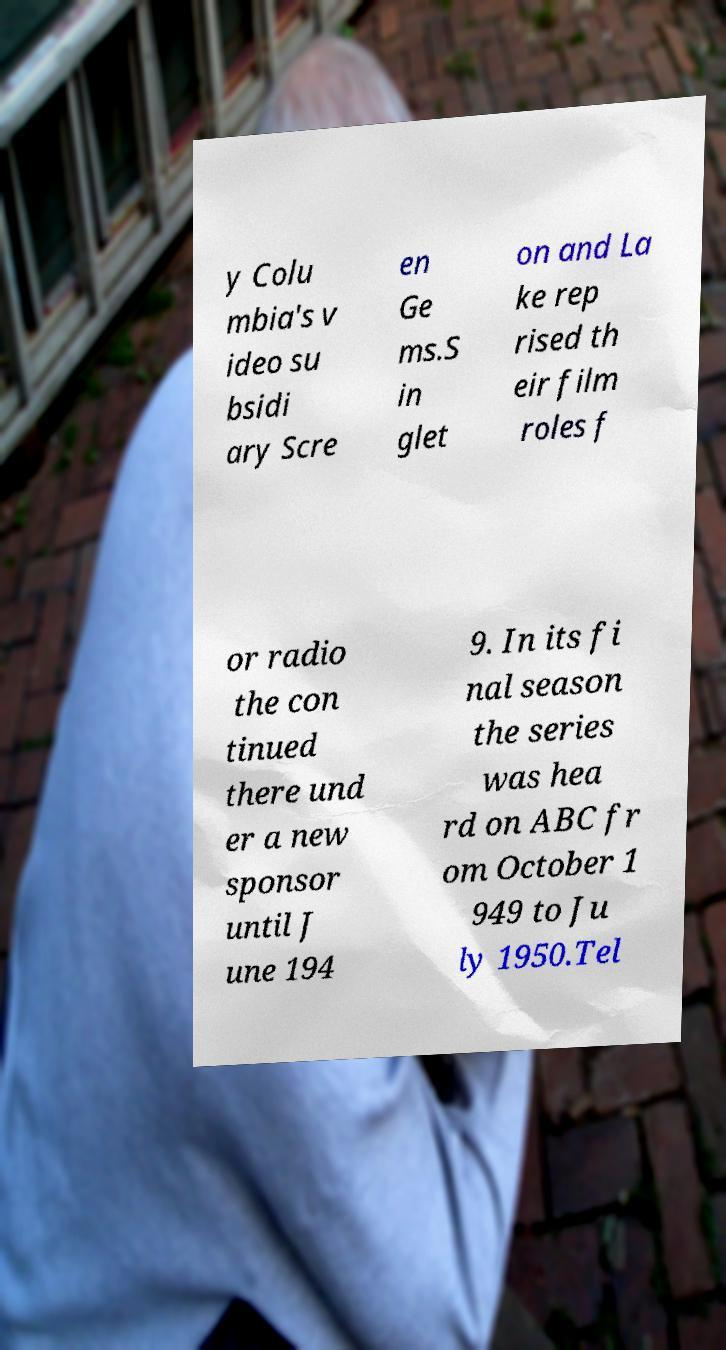I need the written content from this picture converted into text. Can you do that? y Colu mbia's v ideo su bsidi ary Scre en Ge ms.S in glet on and La ke rep rised th eir film roles f or radio the con tinued there und er a new sponsor until J une 194 9. In its fi nal season the series was hea rd on ABC fr om October 1 949 to Ju ly 1950.Tel 